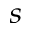<formula> <loc_0><loc_0><loc_500><loc_500>_ { s }</formula> 